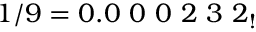<formula> <loc_0><loc_0><loc_500><loc_500>1 / 9 = 0 . 0 \ 0 \ 0 \ 2 \ 3 \ 2 _ { ! }</formula> 